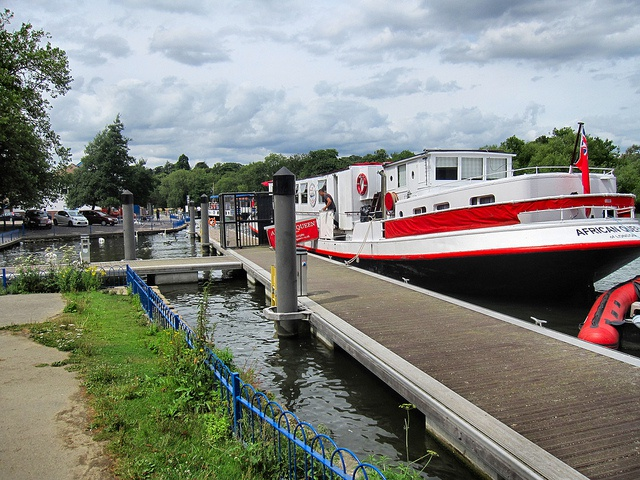Describe the objects in this image and their specific colors. I can see boat in darkgray, lightgray, red, and brown tones, car in darkgray, black, gray, and lightgray tones, car in darkgray, black, and gray tones, car in darkgray, black, gray, and purple tones, and boat in darkgray, black, gray, and lightgray tones in this image. 